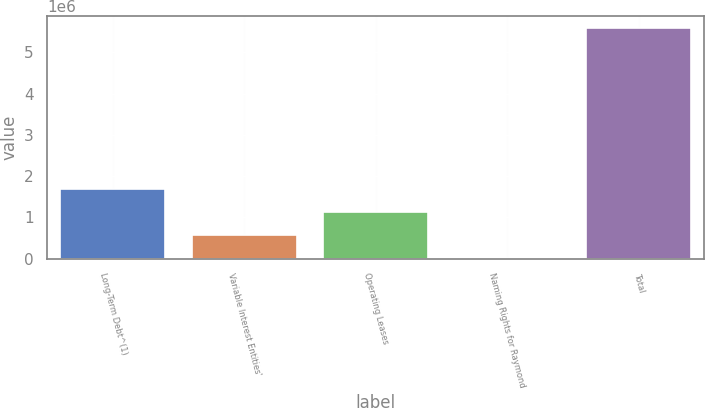Convert chart to OTSL. <chart><loc_0><loc_0><loc_500><loc_500><bar_chart><fcel>Long-Term Debt^(1)<fcel>Variable Interest Entities'<fcel>Operating Leases<fcel>Naming Rights for Raymond<fcel>Total<nl><fcel>1.69417e+06<fcel>578224<fcel>1.1362e+06<fcel>20250<fcel>5.59999e+06<nl></chart> 